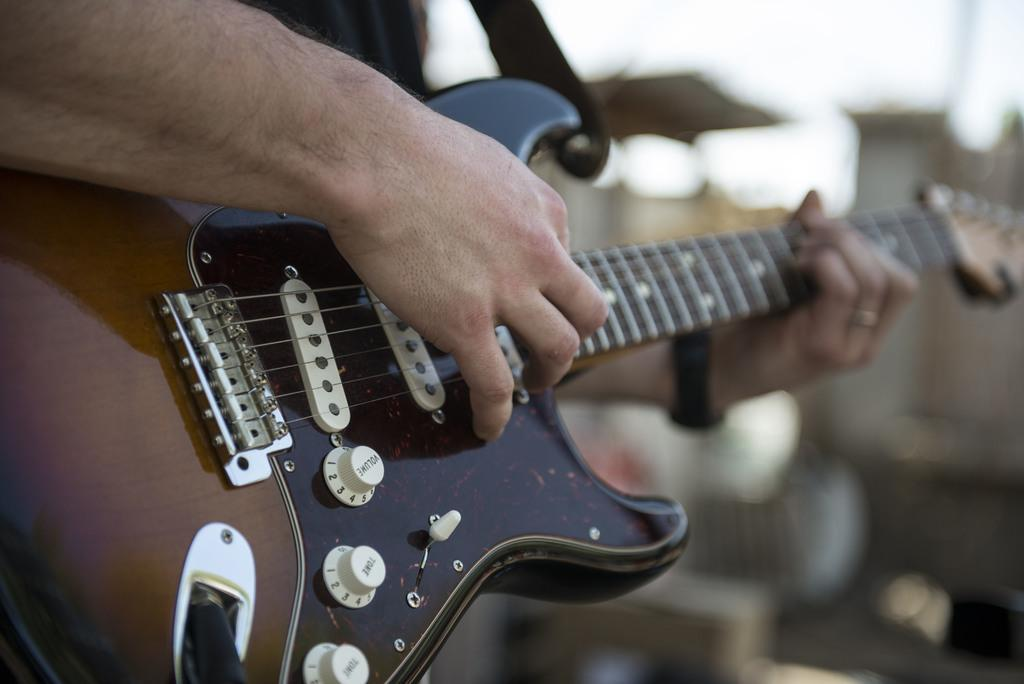What musical instrument is present in the image? There is a guitar in the image. What feature of the guitar is mentioned in the facts? The guitar has strings. Who or what is holding the guitar in the image? A human hand is holding the guitar. What type of pet can be seen playing with the guitar in the image? There is no pet present in the image, and the guitar is not being played by any animal. 